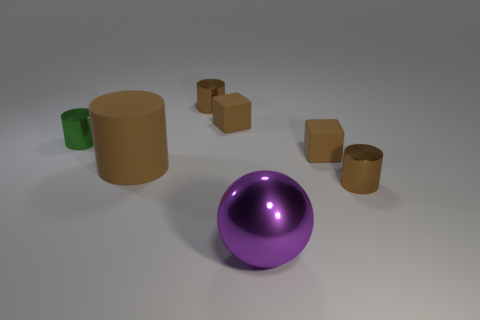What shape is the large thing that is made of the same material as the tiny green object?
Ensure brevity in your answer.  Sphere. Is the shape of the tiny green object the same as the brown metallic object that is in front of the green metal cylinder?
Your answer should be compact. Yes. What material is the tiny brown cylinder that is behind the green metal thing left of the purple metallic ball?
Provide a short and direct response. Metal. How many other objects are there of the same shape as the small green thing?
Ensure brevity in your answer.  3. There is a small metallic object that is on the left side of the large brown rubber thing; does it have the same shape as the big matte object that is on the right side of the small green metal thing?
Ensure brevity in your answer.  Yes. What is the big brown cylinder made of?
Your response must be concise. Rubber. There is a large object behind the big purple shiny ball; what material is it?
Offer a very short reply. Rubber. Are there any other things of the same color as the sphere?
Your answer should be compact. No. What size is the sphere that is the same material as the tiny green cylinder?
Your answer should be compact. Large. How many big things are cylinders or matte things?
Offer a very short reply. 1. 